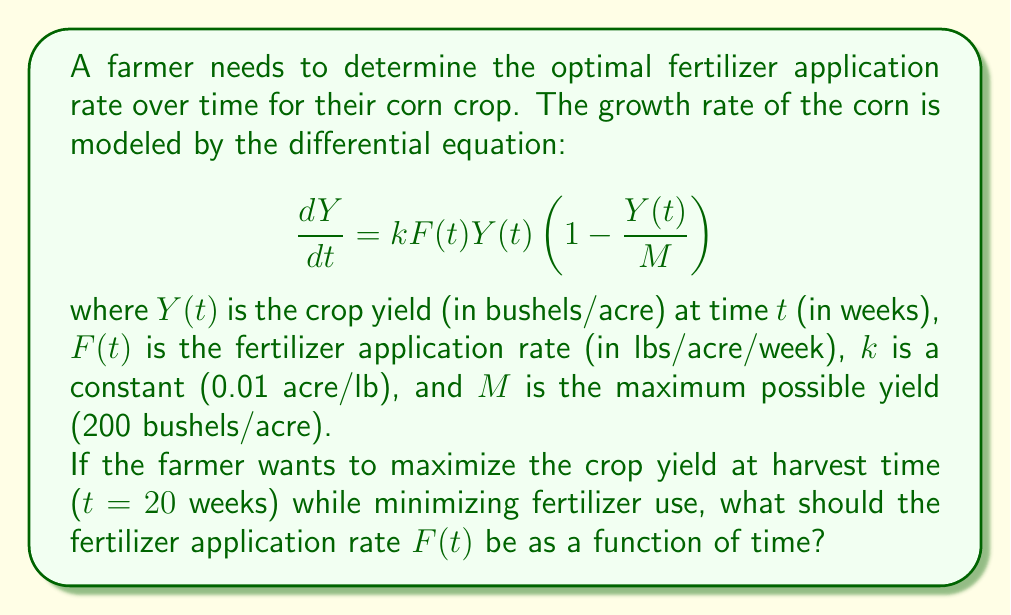Teach me how to tackle this problem. To solve this problem, we need to use optimal control theory, specifically the Pontryagin Maximum Principle. Here's a step-by-step approach:

1) Define the Hamiltonian function:
   $$H = \lambda kF(t)Y(t)(1 - \frac{Y(t)}{M}) - F(t)$$
   where $\lambda$ is the adjoint variable.

2) The optimal control $F^*(t)$ maximizes $H$ at each time $t$. To find this, we differentiate $H$ with respect to $F$:
   $$\frac{\partial H}{\partial F} = \lambda kY(t)(1 - \frac{Y(t)}{M}) - 1$$

3) Set this equal to zero and solve for $F^*(t)$:
   $$\lambda kY(t)(1 - \frac{Y(t)}{M}) - 1 = 0$$
   $$\lambda kY(t)(1 - \frac{Y(t)}{M}) = 1$$
   $$F^*(t) = \begin{cases} 
      F_max & \text{if } \lambda kY(t)(1 - \frac{Y(t)}{M}) > 1 \\
      0 & \text{if } \lambda kY(t)(1 - \frac{Y(t)}{M}) < 1 
   \end{cases}$$

4) This is known as a bang-bang control, where the fertilizer application switches between its maximum rate and zero.

5) The switching function is:
   $$\sigma(t) = \lambda kY(t)(1 - \frac{Y(t)}{M}) - 1$$

6) The optimal strategy is to apply fertilizer at the maximum rate when $\sigma(t) > 0$, and apply no fertilizer when $\sigma(t) < 0$.

7) The exact switching times would depend on the initial conditions and the maximum fertilizer application rate, which are not given in the problem.

Therefore, the optimal fertilizer application strategy is to alternate between periods of maximum application and no application, with the timing of these switches determined by the switching function.
Answer: The optimal fertilizer application rate $F^*(t)$ is a bang-bang control:

$$F^*(t) = \begin{cases} 
   F_max & \text{if } \lambda kY(t)(1 - \frac{Y(t)}{M}) > 1 \\
   0 & \text{if } \lambda kY(t)(1 - \frac{Y(t)}{M}) < 1 
\end{cases}$$

where the switching times are determined by the function $\sigma(t) = \lambda kY(t)(1 - \frac{Y(t)}{M}) - 1$. 